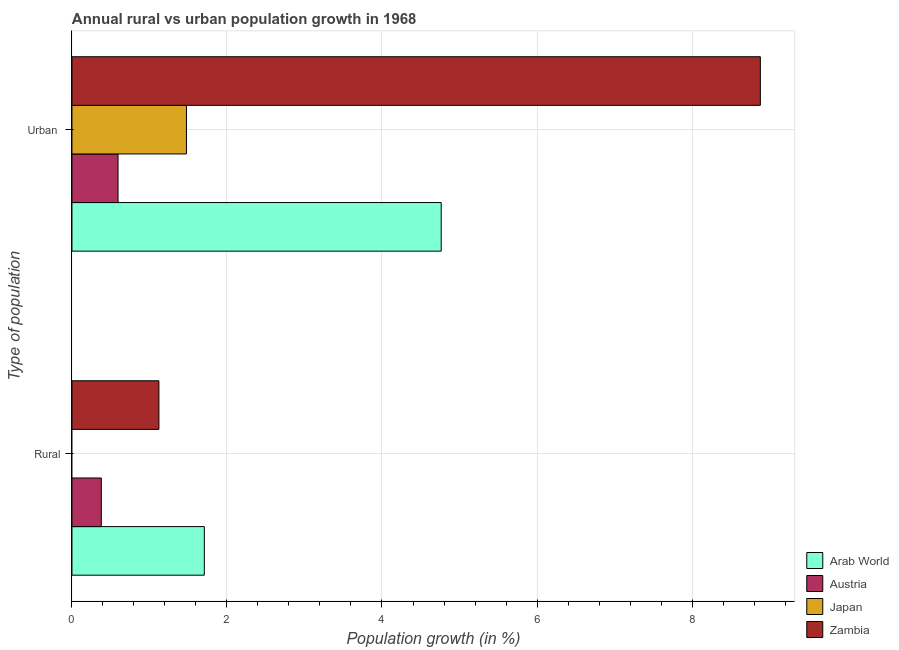How many different coloured bars are there?
Your answer should be compact. 4. How many groups of bars are there?
Make the answer very short. 2. Are the number of bars on each tick of the Y-axis equal?
Keep it short and to the point. No. How many bars are there on the 2nd tick from the top?
Give a very brief answer. 3. What is the label of the 1st group of bars from the top?
Offer a very short reply. Urban . What is the urban population growth in Austria?
Your answer should be very brief. 0.59. Across all countries, what is the maximum urban population growth?
Keep it short and to the point. 8.88. Across all countries, what is the minimum urban population growth?
Keep it short and to the point. 0.59. In which country was the rural population growth maximum?
Offer a very short reply. Arab World. What is the total rural population growth in the graph?
Give a very brief answer. 3.21. What is the difference between the rural population growth in Austria and that in Arab World?
Provide a short and direct response. -1.33. What is the difference between the urban population growth in Japan and the rural population growth in Austria?
Provide a succinct answer. 1.1. What is the average rural population growth per country?
Make the answer very short. 0.8. What is the difference between the rural population growth and urban population growth in Arab World?
Offer a very short reply. -3.06. What is the ratio of the rural population growth in Austria to that in Arab World?
Your response must be concise. 0.22. In how many countries, is the urban population growth greater than the average urban population growth taken over all countries?
Your answer should be very brief. 2. How many countries are there in the graph?
Provide a succinct answer. 4. Does the graph contain any zero values?
Your answer should be very brief. Yes. Does the graph contain grids?
Give a very brief answer. Yes. What is the title of the graph?
Your answer should be compact. Annual rural vs urban population growth in 1968. What is the label or title of the X-axis?
Your answer should be compact. Population growth (in %). What is the label or title of the Y-axis?
Ensure brevity in your answer.  Type of population. What is the Population growth (in %) of Arab World in Rural?
Keep it short and to the point. 1.71. What is the Population growth (in %) in Austria in Rural?
Ensure brevity in your answer.  0.38. What is the Population growth (in %) of Zambia in Rural?
Your answer should be very brief. 1.12. What is the Population growth (in %) in Arab World in Urban ?
Give a very brief answer. 4.76. What is the Population growth (in %) in Austria in Urban ?
Your answer should be compact. 0.59. What is the Population growth (in %) of Japan in Urban ?
Make the answer very short. 1.48. What is the Population growth (in %) in Zambia in Urban ?
Ensure brevity in your answer.  8.88. Across all Type of population, what is the maximum Population growth (in %) in Arab World?
Keep it short and to the point. 4.76. Across all Type of population, what is the maximum Population growth (in %) of Austria?
Your response must be concise. 0.59. Across all Type of population, what is the maximum Population growth (in %) of Japan?
Your answer should be compact. 1.48. Across all Type of population, what is the maximum Population growth (in %) in Zambia?
Your response must be concise. 8.88. Across all Type of population, what is the minimum Population growth (in %) in Arab World?
Offer a terse response. 1.71. Across all Type of population, what is the minimum Population growth (in %) in Austria?
Ensure brevity in your answer.  0.38. Across all Type of population, what is the minimum Population growth (in %) in Japan?
Make the answer very short. 0. Across all Type of population, what is the minimum Population growth (in %) of Zambia?
Offer a terse response. 1.12. What is the total Population growth (in %) in Arab World in the graph?
Provide a short and direct response. 6.47. What is the total Population growth (in %) of Austria in the graph?
Offer a very short reply. 0.97. What is the total Population growth (in %) in Japan in the graph?
Keep it short and to the point. 1.48. What is the total Population growth (in %) in Zambia in the graph?
Your answer should be compact. 10. What is the difference between the Population growth (in %) in Arab World in Rural and that in Urban ?
Your answer should be very brief. -3.06. What is the difference between the Population growth (in %) of Austria in Rural and that in Urban ?
Make the answer very short. -0.22. What is the difference between the Population growth (in %) of Zambia in Rural and that in Urban ?
Your answer should be very brief. -7.76. What is the difference between the Population growth (in %) of Arab World in Rural and the Population growth (in %) of Austria in Urban ?
Give a very brief answer. 1.11. What is the difference between the Population growth (in %) in Arab World in Rural and the Population growth (in %) in Japan in Urban ?
Your answer should be very brief. 0.23. What is the difference between the Population growth (in %) of Arab World in Rural and the Population growth (in %) of Zambia in Urban ?
Your answer should be compact. -7.17. What is the difference between the Population growth (in %) of Austria in Rural and the Population growth (in %) of Japan in Urban ?
Your response must be concise. -1.1. What is the difference between the Population growth (in %) of Austria in Rural and the Population growth (in %) of Zambia in Urban ?
Provide a succinct answer. -8.5. What is the average Population growth (in %) of Arab World per Type of population?
Keep it short and to the point. 3.24. What is the average Population growth (in %) of Austria per Type of population?
Provide a short and direct response. 0.49. What is the average Population growth (in %) of Japan per Type of population?
Make the answer very short. 0.74. What is the average Population growth (in %) in Zambia per Type of population?
Your response must be concise. 5. What is the difference between the Population growth (in %) in Arab World and Population growth (in %) in Austria in Rural?
Ensure brevity in your answer.  1.33. What is the difference between the Population growth (in %) of Arab World and Population growth (in %) of Zambia in Rural?
Keep it short and to the point. 0.59. What is the difference between the Population growth (in %) in Austria and Population growth (in %) in Zambia in Rural?
Your answer should be compact. -0.74. What is the difference between the Population growth (in %) in Arab World and Population growth (in %) in Austria in Urban ?
Ensure brevity in your answer.  4.17. What is the difference between the Population growth (in %) of Arab World and Population growth (in %) of Japan in Urban ?
Give a very brief answer. 3.29. What is the difference between the Population growth (in %) of Arab World and Population growth (in %) of Zambia in Urban ?
Ensure brevity in your answer.  -4.12. What is the difference between the Population growth (in %) of Austria and Population growth (in %) of Japan in Urban ?
Give a very brief answer. -0.88. What is the difference between the Population growth (in %) in Austria and Population growth (in %) in Zambia in Urban ?
Provide a short and direct response. -8.29. What is the difference between the Population growth (in %) of Japan and Population growth (in %) of Zambia in Urban ?
Provide a short and direct response. -7.4. What is the ratio of the Population growth (in %) of Arab World in Rural to that in Urban ?
Keep it short and to the point. 0.36. What is the ratio of the Population growth (in %) in Austria in Rural to that in Urban ?
Your answer should be compact. 0.64. What is the ratio of the Population growth (in %) in Zambia in Rural to that in Urban ?
Ensure brevity in your answer.  0.13. What is the difference between the highest and the second highest Population growth (in %) of Arab World?
Ensure brevity in your answer.  3.06. What is the difference between the highest and the second highest Population growth (in %) of Austria?
Give a very brief answer. 0.22. What is the difference between the highest and the second highest Population growth (in %) in Zambia?
Your response must be concise. 7.76. What is the difference between the highest and the lowest Population growth (in %) in Arab World?
Your answer should be compact. 3.06. What is the difference between the highest and the lowest Population growth (in %) in Austria?
Give a very brief answer. 0.22. What is the difference between the highest and the lowest Population growth (in %) in Japan?
Your answer should be very brief. 1.48. What is the difference between the highest and the lowest Population growth (in %) in Zambia?
Keep it short and to the point. 7.76. 